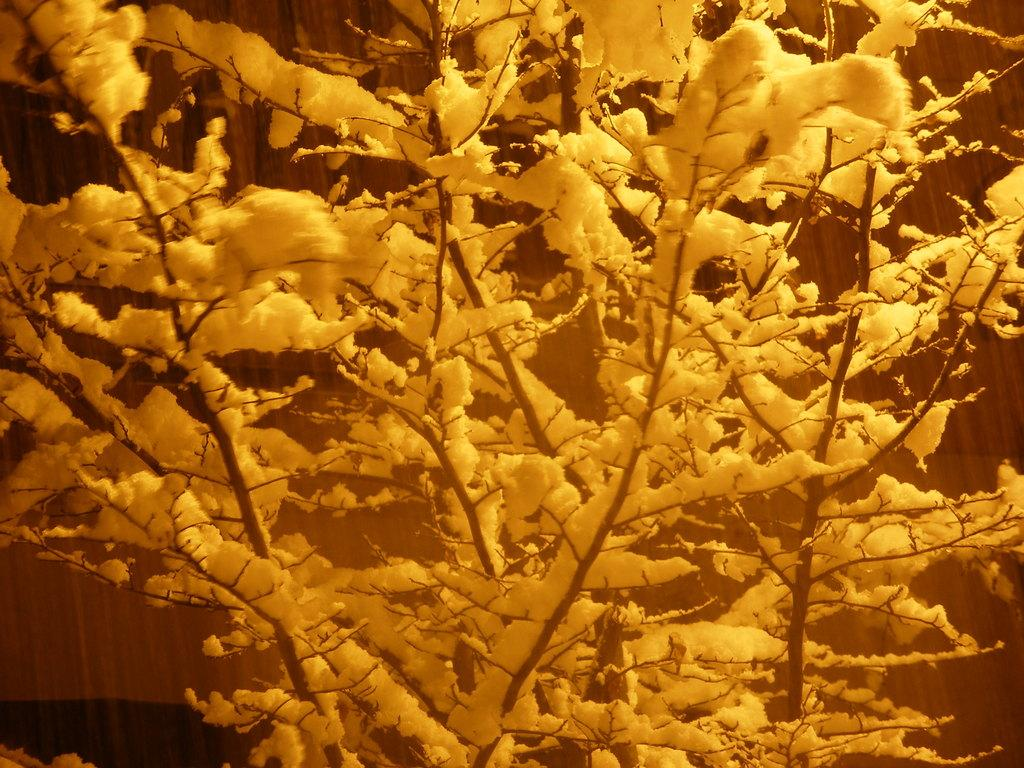What type of tree is visible in the image? There is a dry tree in the image. How is the dry tree affected by the weather? The dry tree is covered with snow. What is the income of the person who owns the crib in the image? There is no crib present in the image, and therefore no information about the owner's income can be determined. 